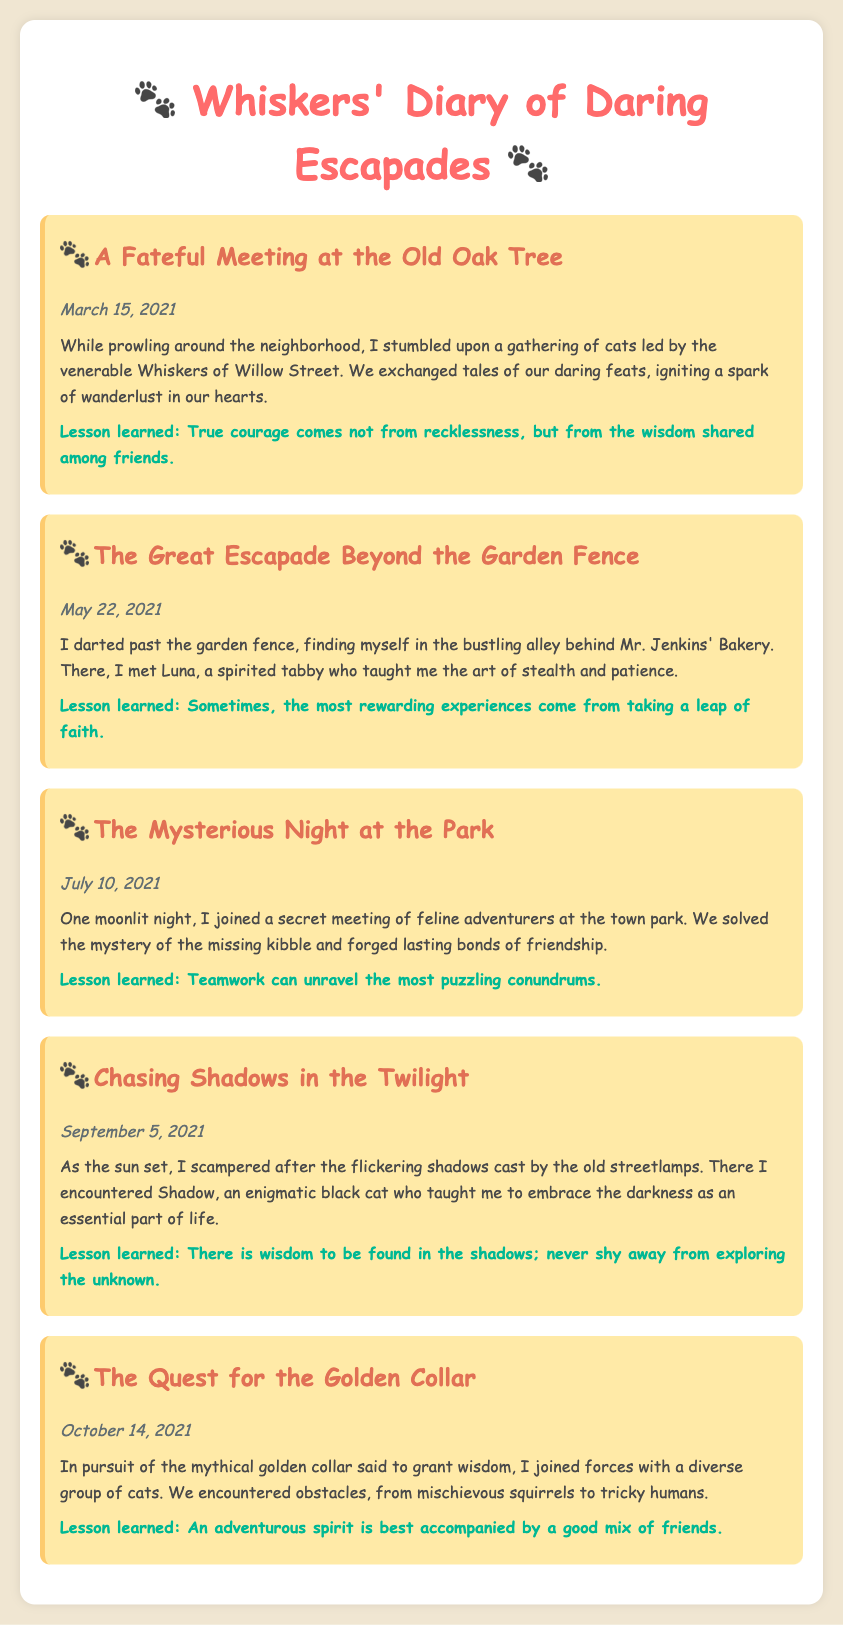What is the title of the diary? The title of the diary is prominently displayed at the top of the document.
Answer: Whiskers' Diary of Daring Escapades When was the first entry made? The date of the first entry can be found in the document.
Answer: March 15, 2021 Who led the gathering of cats in the first entry? The name of the cat leading the gathering is mentioned in the first entry.
Answer: Whiskers of Willow Street What lesson is learned from the second entry? The lesson learned is summarized at the end of the second entry.
Answer: Sometimes, the most rewarding experiences come from taking a leap of faith Which feline adventurer taught about stealth and patience? The name of the feline who taught the lesson on stealth and patience is specified in the second entry.
Answer: Luna How many entries are there in total? The total number of entries is counted from the document.
Answer: Five What event is mentioned in the third entry? The third entry describes a specific event that took place at night.
Answer: A secret meeting of feline adventurers What date is associated with "Chasing Shadows in the Twilight"? The date for the entry on Chasing Shadows is stated in the document.
Answer: September 5, 2021 What is the theme of the last entry? The overall theme can be inferred from the content and challenges faced in the last entry.
Answer: The Quest for the Golden Collar 